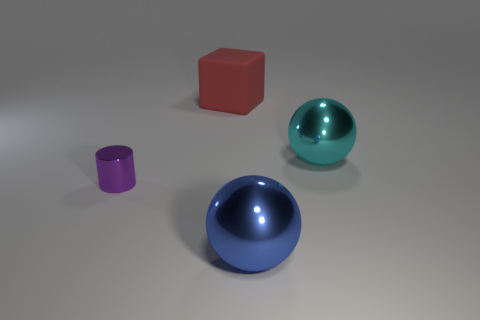Add 4 gray matte balls. How many objects exist? 8 Subtract all cylinders. How many objects are left? 3 Add 2 brown cubes. How many brown cubes exist? 2 Subtract 0 green cubes. How many objects are left? 4 Subtract all small gray rubber blocks. Subtract all red objects. How many objects are left? 3 Add 3 tiny purple objects. How many tiny purple objects are left? 4 